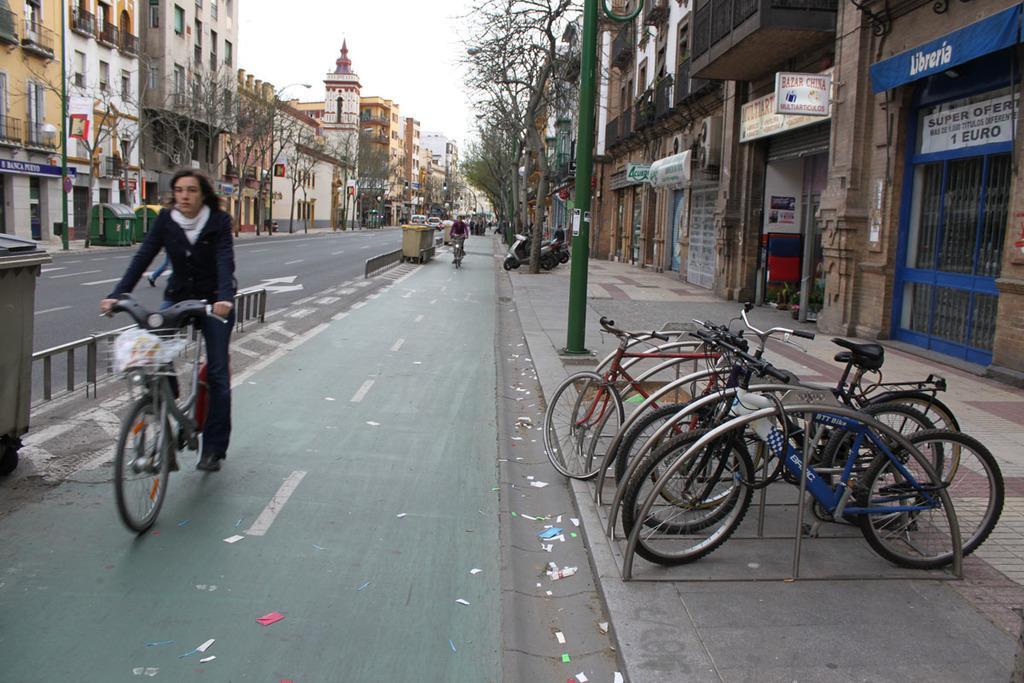Please provide a concise description of this image. In this image we can see many buildings. There are few vehicles in the image. There are few persons riding bicycle in the image. We can see the sky in the image. There are few advertising boards in the image. There are few poles in the image. There is a road in the image. There are few objects in the image. 